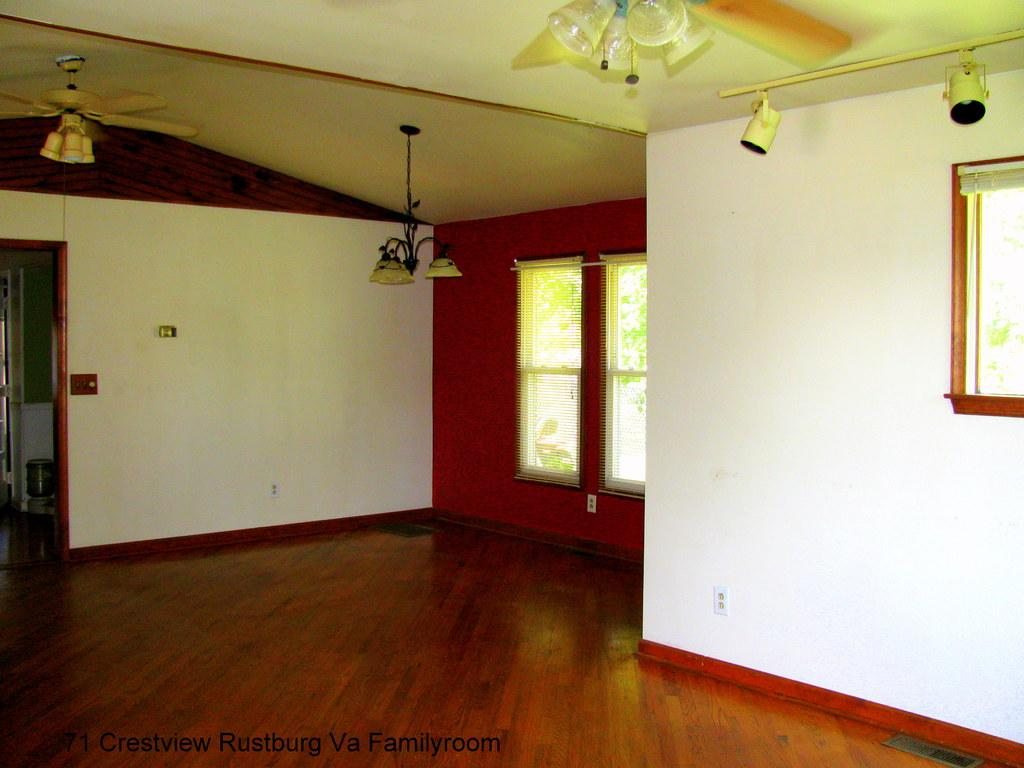What can be seen in the image that allows light and air to enter a room? There is a window in the image. What type of lighting is present in the image? There are metal lamps in the image. What device is used for cooling in the image? There is a fan in the image. What are the long, thin bars used for in the image? There are rods in the image. What is the source of illumination in the image? There are lights in the image. What surface can be seen beneath the objects in the image? There is a floor visible in the image. What type of milk is being poured from the fan in the image? There is no milk or pouring action involving the fan in the image. Can you see any corn growing on the rods in the image? There is no corn or indication of plant growth on the rods in the image. 